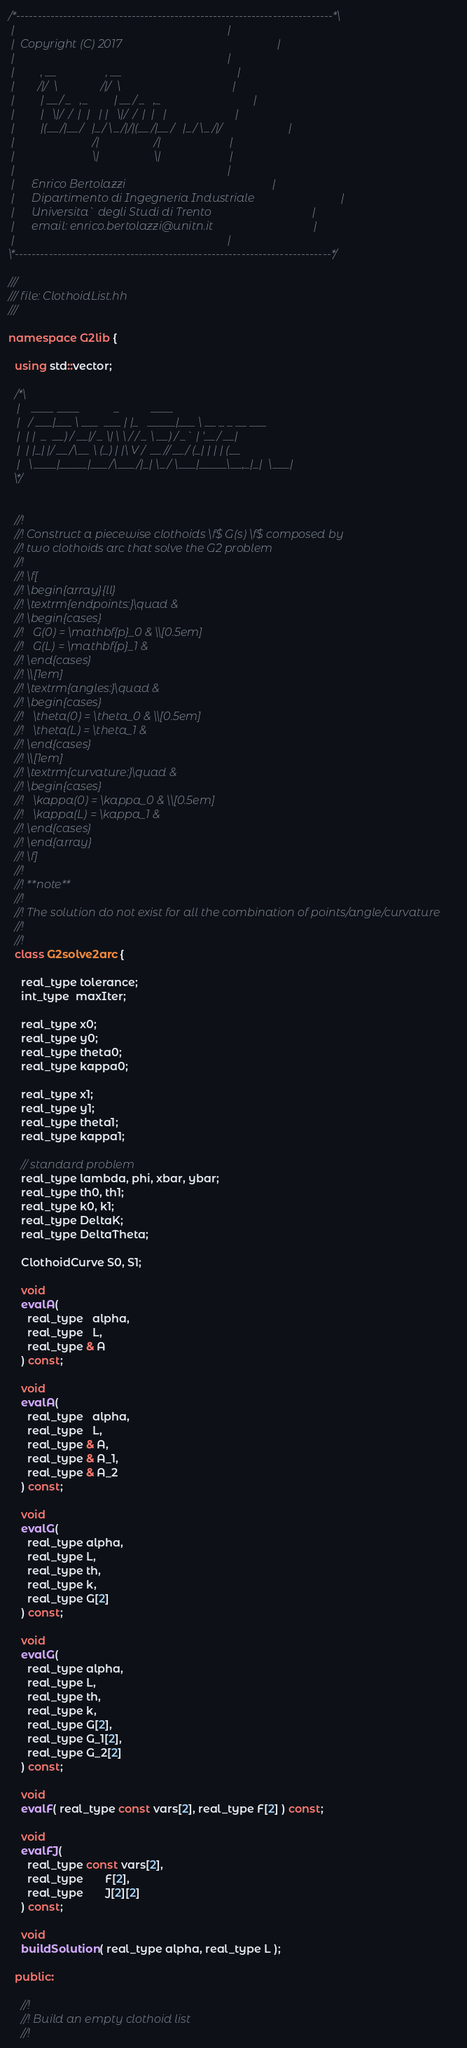<code> <loc_0><loc_0><loc_500><loc_500><_C++_>/*--------------------------------------------------------------------------*\
 |                                                                          |
 |  Copyright (C) 2017                                                      |
 |                                                                          |
 |         , __                 , __                                        |
 |        /|/  \               /|/  \                                       |
 |         | __/ _   ,_         | __/ _   ,_                                |
 |         |   \|/  /  |  |   | |   \|/  /  |  |   |                        |
 |         |(__/|__/   |_/ \_/|/|(__/|__/   |_/ \_/|/                       |
 |                           /|                   /|                        |
 |                           \|                   \|                        |
 |                                                                          |
 |      Enrico Bertolazzi                                                   |
 |      Dipartimento di Ingegneria Industriale                              |
 |      Universita` degli Studi di Trento                                   |
 |      email: enrico.bertolazzi@unitn.it                                   |
 |                                                                          |
\*--------------------------------------------------------------------------*/

///
/// file: ClothoidList.hh
///

namespace G2lib {

  using std::vector;

  /*\
   |    ____ ____            _           ____
   |   / ___|___ \ ___  ___ | |_   _____|___ \ __ _ _ __ ___
   |  | |  _  __) / __|/ _ \| \ \ / / _ \ __) / _` | '__/ __|
   |  | |_| |/ __/\__ \ (_) | |\ V /  __// __/ (_| | | | (__
   |   \____|_____|___/\___/|_| \_/ \___|_____\__,_|_|  \___|
  \*/


  //!
  //! Construct a piecewise clothoids \f$ G(s) \f$ composed by
  //! two clothoids arc that solve the G2 problem
  //!
  //! \f[
  //! \begin{array}{ll}
  //! \textrm{endpoints:}\quad &
  //! \begin{cases}
  //!   G(0) = \mathbf{p}_0 & \\[0.5em]
  //!   G(L) = \mathbf{p}_1 &
  //! \end{cases}
  //! \\[1em]
  //! \textrm{angles:}\quad &
  //! \begin{cases}
  //!   \theta(0) = \theta_0 & \\[0.5em]
  //!   \theta(L) = \theta_1 &
  //! \end{cases}
  //! \\[1em]
  //! \textrm{curvature:}\quad &
  //! \begin{cases}
  //!   \kappa(0) = \kappa_0 & \\[0.5em]
  //!   \kappa(L) = \kappa_1 &
  //! \end{cases}
  //! \end{array}
  //! \f]
  //!
  //! **note**
  //!
  //! The solution do not exist for all the combination of points/angle/curvature
  //!
  //!
  class G2solve2arc {

    real_type tolerance;
    int_type  maxIter;

    real_type x0;
    real_type y0;
    real_type theta0;
    real_type kappa0;

    real_type x1;
    real_type y1;
    real_type theta1;
    real_type kappa1;

    // standard problem
    real_type lambda, phi, xbar, ybar;
    real_type th0, th1;
    real_type k0, k1;
    real_type DeltaK;
    real_type DeltaTheta;

    ClothoidCurve S0, S1;

    void
    evalA(
      real_type   alpha,
      real_type   L,
      real_type & A
    ) const;

    void
    evalA(
      real_type   alpha,
      real_type   L,
      real_type & A,
      real_type & A_1,
      real_type & A_2
    ) const;

    void
    evalG(
      real_type alpha,
      real_type L,
      real_type th,
      real_type k,
      real_type G[2]
    ) const;

    void
    evalG(
      real_type alpha,
      real_type L,
      real_type th,
      real_type k,
      real_type G[2],
      real_type G_1[2],
      real_type G_2[2]
    ) const;

    void
    evalF( real_type const vars[2], real_type F[2] ) const;

    void
    evalFJ(
      real_type const vars[2],
      real_type       F[2],
      real_type       J[2][2]
    ) const;

    void
    buildSolution( real_type alpha, real_type L );

  public:

    //!
    //! Build an empty clothoid list
    //!</code> 